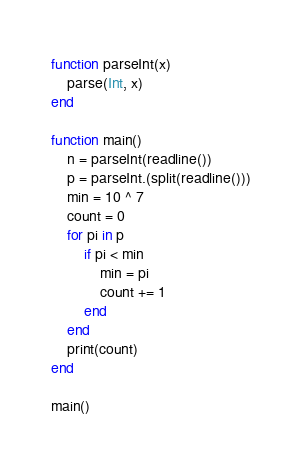Convert code to text. <code><loc_0><loc_0><loc_500><loc_500><_Julia_>function parseInt(x)
    parse(Int, x)
end

function main()
    n = parseInt(readline())
    p = parseInt.(split(readline()))
    min = 10 ^ 7
    count = 0
    for pi in p
        if pi < min
            min = pi
            count += 1
        end
    end
    print(count)
end

main()</code> 